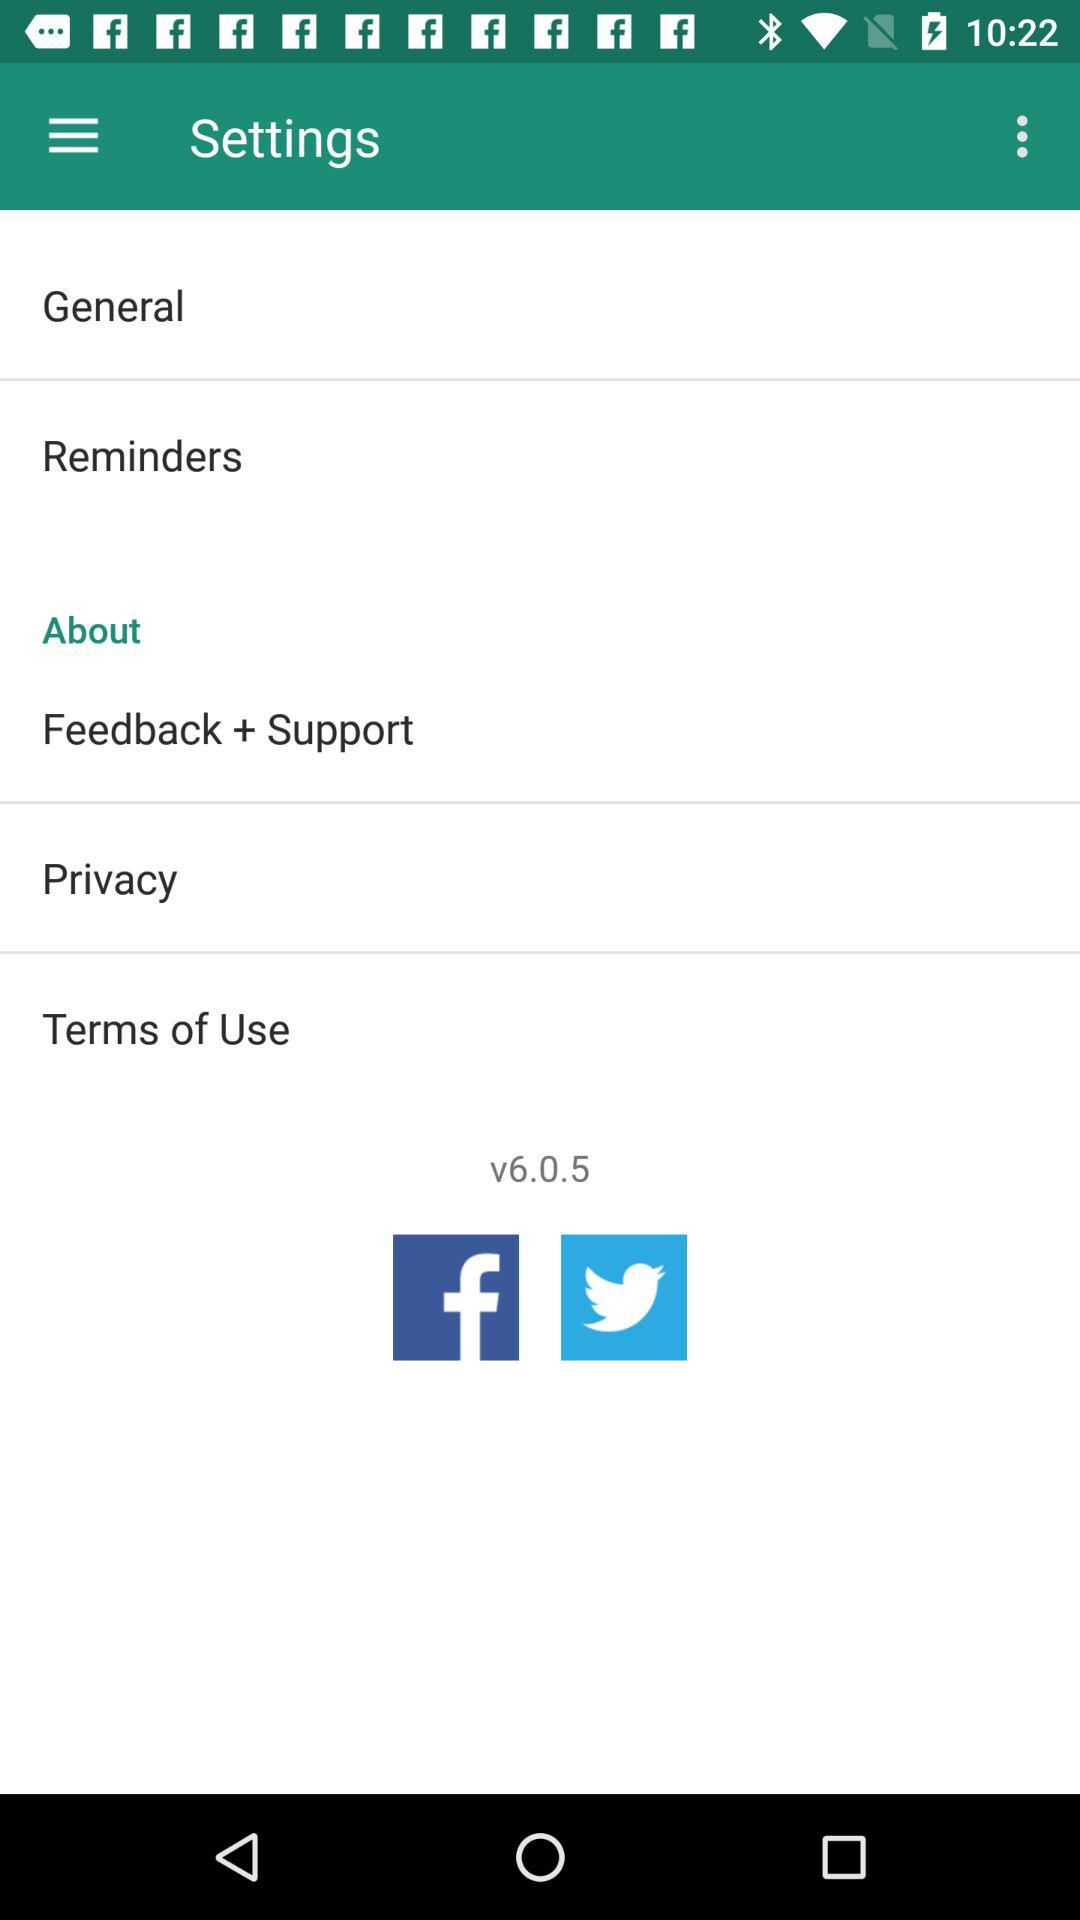What is the version number? The version number is v6.0.5. 